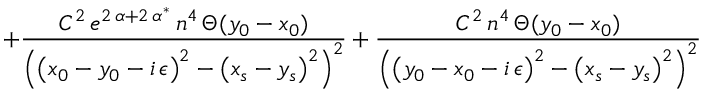Convert formula to latex. <formula><loc_0><loc_0><loc_500><loc_500>+ \frac { C ^ { 2 } \, e ^ { 2 \, \alpha + 2 \, \alpha ^ { * } } \, n ^ { 4 } \, \Theta ( y _ { 0 } - x _ { 0 } ) } { \left ( \left ( x _ { 0 } - y _ { 0 } - i \, \epsilon \right ) ^ { 2 } - \left ( x _ { s } - y _ { s } \right ) ^ { 2 } \right ) ^ { 2 } } + \frac { C ^ { 2 } \, n ^ { 4 } \, \Theta ( y _ { 0 } - x _ { 0 } ) } { \left ( \left ( y _ { 0 } - x _ { 0 } - i \, \epsilon \right ) ^ { 2 } - \left ( x _ { s } - y _ { s } \right ) ^ { 2 } \right ) ^ { 2 } }</formula> 